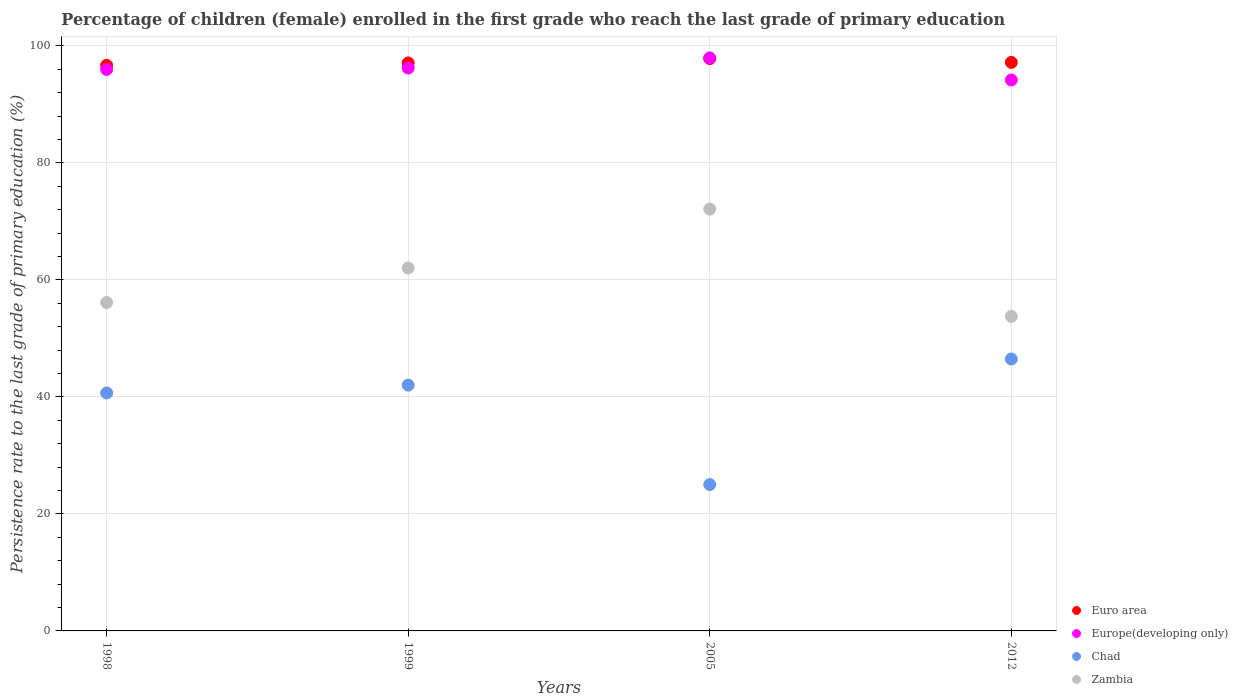Is the number of dotlines equal to the number of legend labels?
Provide a short and direct response. Yes. What is the persistence rate of children in Zambia in 2005?
Keep it short and to the point. 72.1. Across all years, what is the maximum persistence rate of children in Europe(developing only)?
Provide a succinct answer. 97.95. Across all years, what is the minimum persistence rate of children in Europe(developing only)?
Keep it short and to the point. 94.18. What is the total persistence rate of children in Europe(developing only) in the graph?
Offer a very short reply. 384.32. What is the difference between the persistence rate of children in Zambia in 2005 and that in 2012?
Offer a very short reply. 18.34. What is the difference between the persistence rate of children in Zambia in 2005 and the persistence rate of children in Chad in 2012?
Keep it short and to the point. 25.62. What is the average persistence rate of children in Europe(developing only) per year?
Keep it short and to the point. 96.08. In the year 2005, what is the difference between the persistence rate of children in Europe(developing only) and persistence rate of children in Euro area?
Ensure brevity in your answer.  0.12. What is the ratio of the persistence rate of children in Europe(developing only) in 1999 to that in 2012?
Your response must be concise. 1.02. Is the persistence rate of children in Chad in 1999 less than that in 2005?
Keep it short and to the point. No. Is the difference between the persistence rate of children in Europe(developing only) in 2005 and 2012 greater than the difference between the persistence rate of children in Euro area in 2005 and 2012?
Keep it short and to the point. Yes. What is the difference between the highest and the second highest persistence rate of children in Euro area?
Provide a succinct answer. 0.65. What is the difference between the highest and the lowest persistence rate of children in Zambia?
Provide a short and direct response. 18.34. How many dotlines are there?
Make the answer very short. 4. What is the difference between two consecutive major ticks on the Y-axis?
Your answer should be compact. 20. How are the legend labels stacked?
Provide a succinct answer. Vertical. What is the title of the graph?
Ensure brevity in your answer.  Percentage of children (female) enrolled in the first grade who reach the last grade of primary education. What is the label or title of the X-axis?
Your answer should be very brief. Years. What is the label or title of the Y-axis?
Your response must be concise. Persistence rate to the last grade of primary education (%). What is the Persistence rate to the last grade of primary education (%) in Euro area in 1998?
Your answer should be very brief. 96.68. What is the Persistence rate to the last grade of primary education (%) in Europe(developing only) in 1998?
Ensure brevity in your answer.  95.98. What is the Persistence rate to the last grade of primary education (%) in Chad in 1998?
Your response must be concise. 40.68. What is the Persistence rate to the last grade of primary education (%) of Zambia in 1998?
Your answer should be compact. 56.14. What is the Persistence rate to the last grade of primary education (%) in Euro area in 1999?
Offer a terse response. 97.09. What is the Persistence rate to the last grade of primary education (%) in Europe(developing only) in 1999?
Keep it short and to the point. 96.22. What is the Persistence rate to the last grade of primary education (%) of Chad in 1999?
Your answer should be compact. 42.02. What is the Persistence rate to the last grade of primary education (%) of Zambia in 1999?
Give a very brief answer. 62.04. What is the Persistence rate to the last grade of primary education (%) in Euro area in 2005?
Provide a short and direct response. 97.83. What is the Persistence rate to the last grade of primary education (%) of Europe(developing only) in 2005?
Make the answer very short. 97.95. What is the Persistence rate to the last grade of primary education (%) in Chad in 2005?
Provide a succinct answer. 25.02. What is the Persistence rate to the last grade of primary education (%) of Zambia in 2005?
Make the answer very short. 72.1. What is the Persistence rate to the last grade of primary education (%) in Euro area in 2012?
Provide a short and direct response. 97.18. What is the Persistence rate to the last grade of primary education (%) of Europe(developing only) in 2012?
Offer a terse response. 94.18. What is the Persistence rate to the last grade of primary education (%) of Chad in 2012?
Provide a succinct answer. 46.48. What is the Persistence rate to the last grade of primary education (%) in Zambia in 2012?
Make the answer very short. 53.76. Across all years, what is the maximum Persistence rate to the last grade of primary education (%) in Euro area?
Keep it short and to the point. 97.83. Across all years, what is the maximum Persistence rate to the last grade of primary education (%) in Europe(developing only)?
Give a very brief answer. 97.95. Across all years, what is the maximum Persistence rate to the last grade of primary education (%) of Chad?
Offer a very short reply. 46.48. Across all years, what is the maximum Persistence rate to the last grade of primary education (%) in Zambia?
Make the answer very short. 72.1. Across all years, what is the minimum Persistence rate to the last grade of primary education (%) of Euro area?
Your answer should be compact. 96.68. Across all years, what is the minimum Persistence rate to the last grade of primary education (%) in Europe(developing only)?
Give a very brief answer. 94.18. Across all years, what is the minimum Persistence rate to the last grade of primary education (%) of Chad?
Your response must be concise. 25.02. Across all years, what is the minimum Persistence rate to the last grade of primary education (%) in Zambia?
Your answer should be very brief. 53.76. What is the total Persistence rate to the last grade of primary education (%) of Euro area in the graph?
Give a very brief answer. 388.77. What is the total Persistence rate to the last grade of primary education (%) of Europe(developing only) in the graph?
Your response must be concise. 384.32. What is the total Persistence rate to the last grade of primary education (%) in Chad in the graph?
Your answer should be very brief. 154.2. What is the total Persistence rate to the last grade of primary education (%) of Zambia in the graph?
Your answer should be very brief. 244.03. What is the difference between the Persistence rate to the last grade of primary education (%) of Euro area in 1998 and that in 1999?
Keep it short and to the point. -0.41. What is the difference between the Persistence rate to the last grade of primary education (%) in Europe(developing only) in 1998 and that in 1999?
Offer a terse response. -0.24. What is the difference between the Persistence rate to the last grade of primary education (%) of Chad in 1998 and that in 1999?
Offer a very short reply. -1.34. What is the difference between the Persistence rate to the last grade of primary education (%) of Zambia in 1998 and that in 1999?
Your answer should be compact. -5.9. What is the difference between the Persistence rate to the last grade of primary education (%) in Euro area in 1998 and that in 2005?
Your response must be concise. -1.15. What is the difference between the Persistence rate to the last grade of primary education (%) of Europe(developing only) in 1998 and that in 2005?
Your response must be concise. -1.97. What is the difference between the Persistence rate to the last grade of primary education (%) in Chad in 1998 and that in 2005?
Your answer should be very brief. 15.66. What is the difference between the Persistence rate to the last grade of primary education (%) of Zambia in 1998 and that in 2005?
Your response must be concise. -15.96. What is the difference between the Persistence rate to the last grade of primary education (%) of Euro area in 1998 and that in 2012?
Provide a succinct answer. -0.5. What is the difference between the Persistence rate to the last grade of primary education (%) of Europe(developing only) in 1998 and that in 2012?
Offer a very short reply. 1.8. What is the difference between the Persistence rate to the last grade of primary education (%) in Chad in 1998 and that in 2012?
Ensure brevity in your answer.  -5.8. What is the difference between the Persistence rate to the last grade of primary education (%) in Zambia in 1998 and that in 2012?
Provide a succinct answer. 2.38. What is the difference between the Persistence rate to the last grade of primary education (%) of Euro area in 1999 and that in 2005?
Make the answer very short. -0.74. What is the difference between the Persistence rate to the last grade of primary education (%) in Europe(developing only) in 1999 and that in 2005?
Your response must be concise. -1.73. What is the difference between the Persistence rate to the last grade of primary education (%) of Chad in 1999 and that in 2005?
Give a very brief answer. 17. What is the difference between the Persistence rate to the last grade of primary education (%) in Zambia in 1999 and that in 2005?
Your answer should be very brief. -10.06. What is the difference between the Persistence rate to the last grade of primary education (%) of Euro area in 1999 and that in 2012?
Provide a succinct answer. -0.09. What is the difference between the Persistence rate to the last grade of primary education (%) of Europe(developing only) in 1999 and that in 2012?
Your response must be concise. 2.05. What is the difference between the Persistence rate to the last grade of primary education (%) in Chad in 1999 and that in 2012?
Your answer should be very brief. -4.46. What is the difference between the Persistence rate to the last grade of primary education (%) in Zambia in 1999 and that in 2012?
Give a very brief answer. 8.28. What is the difference between the Persistence rate to the last grade of primary education (%) of Euro area in 2005 and that in 2012?
Offer a very short reply. 0.65. What is the difference between the Persistence rate to the last grade of primary education (%) of Europe(developing only) in 2005 and that in 2012?
Offer a very short reply. 3.77. What is the difference between the Persistence rate to the last grade of primary education (%) in Chad in 2005 and that in 2012?
Offer a terse response. -21.46. What is the difference between the Persistence rate to the last grade of primary education (%) of Zambia in 2005 and that in 2012?
Provide a succinct answer. 18.34. What is the difference between the Persistence rate to the last grade of primary education (%) in Euro area in 1998 and the Persistence rate to the last grade of primary education (%) in Europe(developing only) in 1999?
Your answer should be very brief. 0.46. What is the difference between the Persistence rate to the last grade of primary education (%) of Euro area in 1998 and the Persistence rate to the last grade of primary education (%) of Chad in 1999?
Your answer should be very brief. 54.66. What is the difference between the Persistence rate to the last grade of primary education (%) of Euro area in 1998 and the Persistence rate to the last grade of primary education (%) of Zambia in 1999?
Provide a short and direct response. 34.64. What is the difference between the Persistence rate to the last grade of primary education (%) of Europe(developing only) in 1998 and the Persistence rate to the last grade of primary education (%) of Chad in 1999?
Offer a very short reply. 53.96. What is the difference between the Persistence rate to the last grade of primary education (%) of Europe(developing only) in 1998 and the Persistence rate to the last grade of primary education (%) of Zambia in 1999?
Provide a succinct answer. 33.94. What is the difference between the Persistence rate to the last grade of primary education (%) in Chad in 1998 and the Persistence rate to the last grade of primary education (%) in Zambia in 1999?
Provide a succinct answer. -21.36. What is the difference between the Persistence rate to the last grade of primary education (%) in Euro area in 1998 and the Persistence rate to the last grade of primary education (%) in Europe(developing only) in 2005?
Provide a succinct answer. -1.27. What is the difference between the Persistence rate to the last grade of primary education (%) of Euro area in 1998 and the Persistence rate to the last grade of primary education (%) of Chad in 2005?
Your answer should be compact. 71.66. What is the difference between the Persistence rate to the last grade of primary education (%) of Euro area in 1998 and the Persistence rate to the last grade of primary education (%) of Zambia in 2005?
Give a very brief answer. 24.58. What is the difference between the Persistence rate to the last grade of primary education (%) of Europe(developing only) in 1998 and the Persistence rate to the last grade of primary education (%) of Chad in 2005?
Give a very brief answer. 70.96. What is the difference between the Persistence rate to the last grade of primary education (%) in Europe(developing only) in 1998 and the Persistence rate to the last grade of primary education (%) in Zambia in 2005?
Your response must be concise. 23.88. What is the difference between the Persistence rate to the last grade of primary education (%) in Chad in 1998 and the Persistence rate to the last grade of primary education (%) in Zambia in 2005?
Provide a short and direct response. -31.42. What is the difference between the Persistence rate to the last grade of primary education (%) of Euro area in 1998 and the Persistence rate to the last grade of primary education (%) of Europe(developing only) in 2012?
Your answer should be very brief. 2.5. What is the difference between the Persistence rate to the last grade of primary education (%) of Euro area in 1998 and the Persistence rate to the last grade of primary education (%) of Chad in 2012?
Offer a very short reply. 50.2. What is the difference between the Persistence rate to the last grade of primary education (%) of Euro area in 1998 and the Persistence rate to the last grade of primary education (%) of Zambia in 2012?
Your answer should be very brief. 42.92. What is the difference between the Persistence rate to the last grade of primary education (%) of Europe(developing only) in 1998 and the Persistence rate to the last grade of primary education (%) of Chad in 2012?
Your response must be concise. 49.5. What is the difference between the Persistence rate to the last grade of primary education (%) in Europe(developing only) in 1998 and the Persistence rate to the last grade of primary education (%) in Zambia in 2012?
Keep it short and to the point. 42.22. What is the difference between the Persistence rate to the last grade of primary education (%) of Chad in 1998 and the Persistence rate to the last grade of primary education (%) of Zambia in 2012?
Your response must be concise. -13.08. What is the difference between the Persistence rate to the last grade of primary education (%) of Euro area in 1999 and the Persistence rate to the last grade of primary education (%) of Europe(developing only) in 2005?
Offer a terse response. -0.86. What is the difference between the Persistence rate to the last grade of primary education (%) in Euro area in 1999 and the Persistence rate to the last grade of primary education (%) in Chad in 2005?
Your answer should be very brief. 72.07. What is the difference between the Persistence rate to the last grade of primary education (%) of Euro area in 1999 and the Persistence rate to the last grade of primary education (%) of Zambia in 2005?
Provide a succinct answer. 24.99. What is the difference between the Persistence rate to the last grade of primary education (%) in Europe(developing only) in 1999 and the Persistence rate to the last grade of primary education (%) in Chad in 2005?
Provide a short and direct response. 71.2. What is the difference between the Persistence rate to the last grade of primary education (%) of Europe(developing only) in 1999 and the Persistence rate to the last grade of primary education (%) of Zambia in 2005?
Make the answer very short. 24.12. What is the difference between the Persistence rate to the last grade of primary education (%) of Chad in 1999 and the Persistence rate to the last grade of primary education (%) of Zambia in 2005?
Keep it short and to the point. -30.08. What is the difference between the Persistence rate to the last grade of primary education (%) of Euro area in 1999 and the Persistence rate to the last grade of primary education (%) of Europe(developing only) in 2012?
Give a very brief answer. 2.91. What is the difference between the Persistence rate to the last grade of primary education (%) in Euro area in 1999 and the Persistence rate to the last grade of primary education (%) in Chad in 2012?
Provide a short and direct response. 50.61. What is the difference between the Persistence rate to the last grade of primary education (%) in Euro area in 1999 and the Persistence rate to the last grade of primary education (%) in Zambia in 2012?
Your answer should be very brief. 43.33. What is the difference between the Persistence rate to the last grade of primary education (%) of Europe(developing only) in 1999 and the Persistence rate to the last grade of primary education (%) of Chad in 2012?
Provide a short and direct response. 49.74. What is the difference between the Persistence rate to the last grade of primary education (%) of Europe(developing only) in 1999 and the Persistence rate to the last grade of primary education (%) of Zambia in 2012?
Provide a succinct answer. 42.46. What is the difference between the Persistence rate to the last grade of primary education (%) of Chad in 1999 and the Persistence rate to the last grade of primary education (%) of Zambia in 2012?
Offer a terse response. -11.74. What is the difference between the Persistence rate to the last grade of primary education (%) in Euro area in 2005 and the Persistence rate to the last grade of primary education (%) in Europe(developing only) in 2012?
Ensure brevity in your answer.  3.65. What is the difference between the Persistence rate to the last grade of primary education (%) in Euro area in 2005 and the Persistence rate to the last grade of primary education (%) in Chad in 2012?
Your answer should be compact. 51.35. What is the difference between the Persistence rate to the last grade of primary education (%) of Euro area in 2005 and the Persistence rate to the last grade of primary education (%) of Zambia in 2012?
Provide a succinct answer. 44.07. What is the difference between the Persistence rate to the last grade of primary education (%) in Europe(developing only) in 2005 and the Persistence rate to the last grade of primary education (%) in Chad in 2012?
Keep it short and to the point. 51.47. What is the difference between the Persistence rate to the last grade of primary education (%) of Europe(developing only) in 2005 and the Persistence rate to the last grade of primary education (%) of Zambia in 2012?
Ensure brevity in your answer.  44.19. What is the difference between the Persistence rate to the last grade of primary education (%) in Chad in 2005 and the Persistence rate to the last grade of primary education (%) in Zambia in 2012?
Provide a succinct answer. -28.74. What is the average Persistence rate to the last grade of primary education (%) in Euro area per year?
Offer a very short reply. 97.19. What is the average Persistence rate to the last grade of primary education (%) of Europe(developing only) per year?
Provide a short and direct response. 96.08. What is the average Persistence rate to the last grade of primary education (%) in Chad per year?
Give a very brief answer. 38.55. What is the average Persistence rate to the last grade of primary education (%) of Zambia per year?
Provide a short and direct response. 61.01. In the year 1998, what is the difference between the Persistence rate to the last grade of primary education (%) of Euro area and Persistence rate to the last grade of primary education (%) of Europe(developing only)?
Provide a short and direct response. 0.7. In the year 1998, what is the difference between the Persistence rate to the last grade of primary education (%) in Euro area and Persistence rate to the last grade of primary education (%) in Chad?
Provide a succinct answer. 56. In the year 1998, what is the difference between the Persistence rate to the last grade of primary education (%) in Euro area and Persistence rate to the last grade of primary education (%) in Zambia?
Your response must be concise. 40.54. In the year 1998, what is the difference between the Persistence rate to the last grade of primary education (%) of Europe(developing only) and Persistence rate to the last grade of primary education (%) of Chad?
Offer a very short reply. 55.3. In the year 1998, what is the difference between the Persistence rate to the last grade of primary education (%) in Europe(developing only) and Persistence rate to the last grade of primary education (%) in Zambia?
Your answer should be very brief. 39.84. In the year 1998, what is the difference between the Persistence rate to the last grade of primary education (%) of Chad and Persistence rate to the last grade of primary education (%) of Zambia?
Offer a very short reply. -15.46. In the year 1999, what is the difference between the Persistence rate to the last grade of primary education (%) of Euro area and Persistence rate to the last grade of primary education (%) of Europe(developing only)?
Provide a short and direct response. 0.86. In the year 1999, what is the difference between the Persistence rate to the last grade of primary education (%) of Euro area and Persistence rate to the last grade of primary education (%) of Chad?
Your answer should be compact. 55.07. In the year 1999, what is the difference between the Persistence rate to the last grade of primary education (%) of Euro area and Persistence rate to the last grade of primary education (%) of Zambia?
Make the answer very short. 35.05. In the year 1999, what is the difference between the Persistence rate to the last grade of primary education (%) in Europe(developing only) and Persistence rate to the last grade of primary education (%) in Chad?
Give a very brief answer. 54.2. In the year 1999, what is the difference between the Persistence rate to the last grade of primary education (%) of Europe(developing only) and Persistence rate to the last grade of primary education (%) of Zambia?
Your answer should be very brief. 34.19. In the year 1999, what is the difference between the Persistence rate to the last grade of primary education (%) in Chad and Persistence rate to the last grade of primary education (%) in Zambia?
Your answer should be compact. -20.02. In the year 2005, what is the difference between the Persistence rate to the last grade of primary education (%) in Euro area and Persistence rate to the last grade of primary education (%) in Europe(developing only)?
Offer a very short reply. -0.12. In the year 2005, what is the difference between the Persistence rate to the last grade of primary education (%) of Euro area and Persistence rate to the last grade of primary education (%) of Chad?
Provide a short and direct response. 72.81. In the year 2005, what is the difference between the Persistence rate to the last grade of primary education (%) of Euro area and Persistence rate to the last grade of primary education (%) of Zambia?
Your response must be concise. 25.73. In the year 2005, what is the difference between the Persistence rate to the last grade of primary education (%) in Europe(developing only) and Persistence rate to the last grade of primary education (%) in Chad?
Provide a succinct answer. 72.93. In the year 2005, what is the difference between the Persistence rate to the last grade of primary education (%) in Europe(developing only) and Persistence rate to the last grade of primary education (%) in Zambia?
Ensure brevity in your answer.  25.85. In the year 2005, what is the difference between the Persistence rate to the last grade of primary education (%) of Chad and Persistence rate to the last grade of primary education (%) of Zambia?
Ensure brevity in your answer.  -47.08. In the year 2012, what is the difference between the Persistence rate to the last grade of primary education (%) of Euro area and Persistence rate to the last grade of primary education (%) of Europe(developing only)?
Offer a very short reply. 3. In the year 2012, what is the difference between the Persistence rate to the last grade of primary education (%) of Euro area and Persistence rate to the last grade of primary education (%) of Chad?
Provide a succinct answer. 50.7. In the year 2012, what is the difference between the Persistence rate to the last grade of primary education (%) of Euro area and Persistence rate to the last grade of primary education (%) of Zambia?
Provide a short and direct response. 43.42. In the year 2012, what is the difference between the Persistence rate to the last grade of primary education (%) in Europe(developing only) and Persistence rate to the last grade of primary education (%) in Chad?
Offer a very short reply. 47.7. In the year 2012, what is the difference between the Persistence rate to the last grade of primary education (%) of Europe(developing only) and Persistence rate to the last grade of primary education (%) of Zambia?
Your response must be concise. 40.42. In the year 2012, what is the difference between the Persistence rate to the last grade of primary education (%) in Chad and Persistence rate to the last grade of primary education (%) in Zambia?
Your response must be concise. -7.28. What is the ratio of the Persistence rate to the last grade of primary education (%) of Euro area in 1998 to that in 1999?
Ensure brevity in your answer.  1. What is the ratio of the Persistence rate to the last grade of primary education (%) of Chad in 1998 to that in 1999?
Make the answer very short. 0.97. What is the ratio of the Persistence rate to the last grade of primary education (%) of Zambia in 1998 to that in 1999?
Give a very brief answer. 0.9. What is the ratio of the Persistence rate to the last grade of primary education (%) of Europe(developing only) in 1998 to that in 2005?
Give a very brief answer. 0.98. What is the ratio of the Persistence rate to the last grade of primary education (%) of Chad in 1998 to that in 2005?
Give a very brief answer. 1.63. What is the ratio of the Persistence rate to the last grade of primary education (%) in Zambia in 1998 to that in 2005?
Your answer should be compact. 0.78. What is the ratio of the Persistence rate to the last grade of primary education (%) of Europe(developing only) in 1998 to that in 2012?
Your response must be concise. 1.02. What is the ratio of the Persistence rate to the last grade of primary education (%) in Chad in 1998 to that in 2012?
Provide a short and direct response. 0.88. What is the ratio of the Persistence rate to the last grade of primary education (%) of Zambia in 1998 to that in 2012?
Offer a terse response. 1.04. What is the ratio of the Persistence rate to the last grade of primary education (%) in Europe(developing only) in 1999 to that in 2005?
Make the answer very short. 0.98. What is the ratio of the Persistence rate to the last grade of primary education (%) in Chad in 1999 to that in 2005?
Keep it short and to the point. 1.68. What is the ratio of the Persistence rate to the last grade of primary education (%) of Zambia in 1999 to that in 2005?
Offer a terse response. 0.86. What is the ratio of the Persistence rate to the last grade of primary education (%) in Europe(developing only) in 1999 to that in 2012?
Ensure brevity in your answer.  1.02. What is the ratio of the Persistence rate to the last grade of primary education (%) in Chad in 1999 to that in 2012?
Provide a succinct answer. 0.9. What is the ratio of the Persistence rate to the last grade of primary education (%) of Zambia in 1999 to that in 2012?
Offer a terse response. 1.15. What is the ratio of the Persistence rate to the last grade of primary education (%) of Europe(developing only) in 2005 to that in 2012?
Provide a succinct answer. 1.04. What is the ratio of the Persistence rate to the last grade of primary education (%) of Chad in 2005 to that in 2012?
Offer a very short reply. 0.54. What is the ratio of the Persistence rate to the last grade of primary education (%) in Zambia in 2005 to that in 2012?
Your response must be concise. 1.34. What is the difference between the highest and the second highest Persistence rate to the last grade of primary education (%) of Euro area?
Make the answer very short. 0.65. What is the difference between the highest and the second highest Persistence rate to the last grade of primary education (%) of Europe(developing only)?
Keep it short and to the point. 1.73. What is the difference between the highest and the second highest Persistence rate to the last grade of primary education (%) in Chad?
Offer a very short reply. 4.46. What is the difference between the highest and the second highest Persistence rate to the last grade of primary education (%) in Zambia?
Provide a short and direct response. 10.06. What is the difference between the highest and the lowest Persistence rate to the last grade of primary education (%) of Euro area?
Your answer should be very brief. 1.15. What is the difference between the highest and the lowest Persistence rate to the last grade of primary education (%) of Europe(developing only)?
Keep it short and to the point. 3.77. What is the difference between the highest and the lowest Persistence rate to the last grade of primary education (%) in Chad?
Offer a very short reply. 21.46. What is the difference between the highest and the lowest Persistence rate to the last grade of primary education (%) of Zambia?
Your answer should be compact. 18.34. 